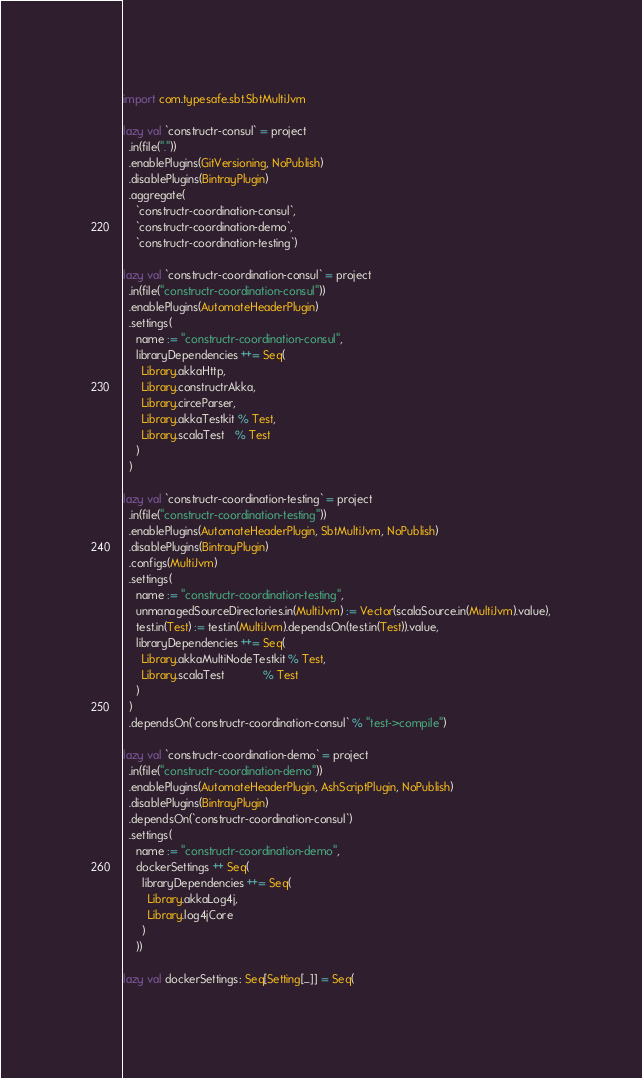Convert code to text. <code><loc_0><loc_0><loc_500><loc_500><_Scala_>import com.typesafe.sbt.SbtMultiJvm

lazy val `constructr-consul` = project
  .in(file("."))
  .enablePlugins(GitVersioning, NoPublish)
  .disablePlugins(BintrayPlugin)
  .aggregate(
    `constructr-coordination-consul`,
    `constructr-coordination-demo`,
    `constructr-coordination-testing`)

lazy val `constructr-coordination-consul` = project
  .in(file("constructr-coordination-consul"))
  .enablePlugins(AutomateHeaderPlugin)
  .settings(
    name := "constructr-coordination-consul",
    libraryDependencies ++= Seq(
      Library.akkaHttp,
      Library.constructrAkka,
      Library.circeParser,
      Library.akkaTestkit % Test,
      Library.scalaTest   % Test
    )
  )

lazy val `constructr-coordination-testing` = project
  .in(file("constructr-coordination-testing"))
  .enablePlugins(AutomateHeaderPlugin, SbtMultiJvm, NoPublish)
  .disablePlugins(BintrayPlugin)
  .configs(MultiJvm)
  .settings(
    name := "constructr-coordination-testing",
    unmanagedSourceDirectories.in(MultiJvm) := Vector(scalaSource.in(MultiJvm).value),
    test.in(Test) := test.in(MultiJvm).dependsOn(test.in(Test)).value,
    libraryDependencies ++= Seq(
      Library.akkaMultiNodeTestkit % Test,
      Library.scalaTest            % Test
    )
  )
  .dependsOn(`constructr-coordination-consul` % "test->compile")

lazy val `constructr-coordination-demo` = project
  .in(file("constructr-coordination-demo"))
  .enablePlugins(AutomateHeaderPlugin, AshScriptPlugin, NoPublish)
  .disablePlugins(BintrayPlugin)
  .dependsOn(`constructr-coordination-consul`)
  .settings(
    name := "constructr-coordination-demo",
    dockerSettings ++ Seq(
      libraryDependencies ++= Seq(
        Library.akkaLog4j,
        Library.log4jCore
      )
    ))

lazy val dockerSettings: Seq[Setting[_]] = Seq(</code> 